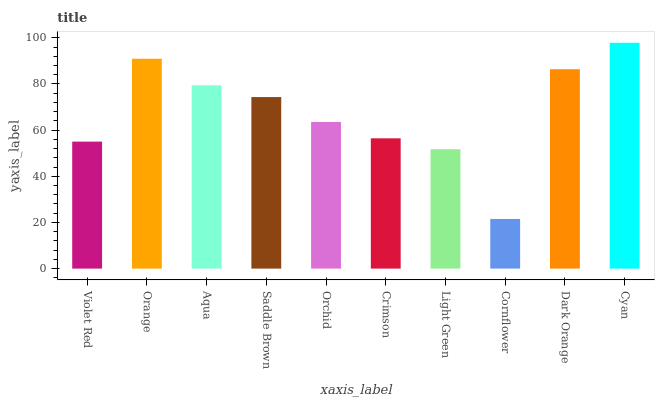Is Orange the minimum?
Answer yes or no. No. Is Orange the maximum?
Answer yes or no. No. Is Orange greater than Violet Red?
Answer yes or no. Yes. Is Violet Red less than Orange?
Answer yes or no. Yes. Is Violet Red greater than Orange?
Answer yes or no. No. Is Orange less than Violet Red?
Answer yes or no. No. Is Saddle Brown the high median?
Answer yes or no. Yes. Is Orchid the low median?
Answer yes or no. Yes. Is Cornflower the high median?
Answer yes or no. No. Is Cyan the low median?
Answer yes or no. No. 